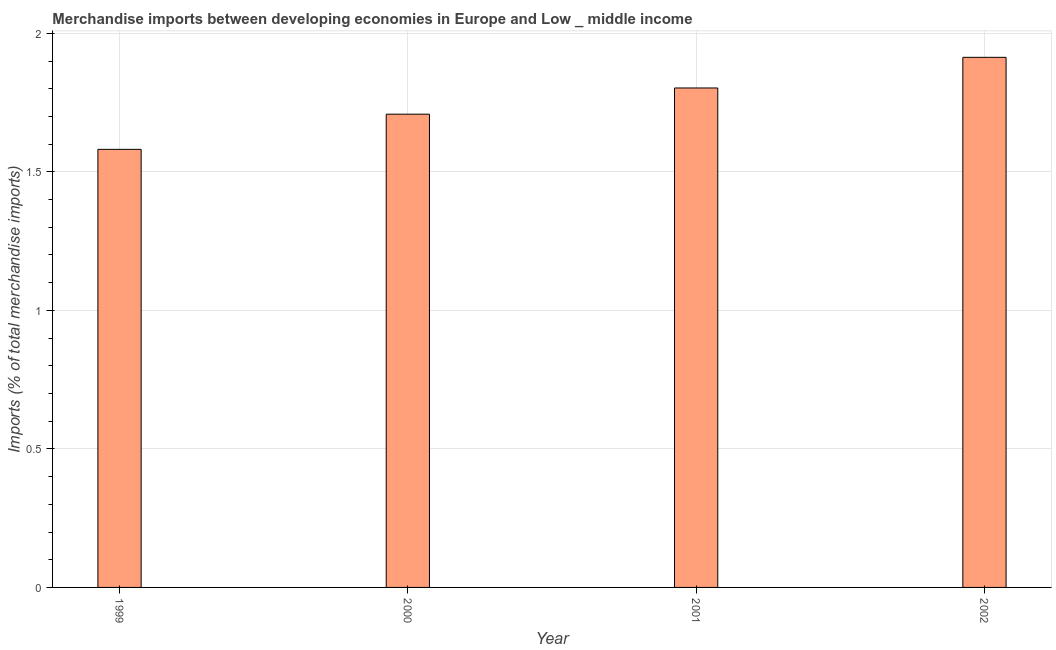What is the title of the graph?
Make the answer very short. Merchandise imports between developing economies in Europe and Low _ middle income. What is the label or title of the Y-axis?
Give a very brief answer. Imports (% of total merchandise imports). What is the merchandise imports in 2002?
Offer a very short reply. 1.91. Across all years, what is the maximum merchandise imports?
Provide a short and direct response. 1.91. Across all years, what is the minimum merchandise imports?
Your response must be concise. 1.58. In which year was the merchandise imports maximum?
Provide a succinct answer. 2002. In which year was the merchandise imports minimum?
Make the answer very short. 1999. What is the sum of the merchandise imports?
Give a very brief answer. 7.01. What is the difference between the merchandise imports in 2001 and 2002?
Offer a terse response. -0.11. What is the average merchandise imports per year?
Your answer should be very brief. 1.75. What is the median merchandise imports?
Provide a short and direct response. 1.76. What is the ratio of the merchandise imports in 1999 to that in 2000?
Give a very brief answer. 0.93. What is the difference between the highest and the second highest merchandise imports?
Your answer should be very brief. 0.11. What is the difference between the highest and the lowest merchandise imports?
Your answer should be compact. 0.33. In how many years, is the merchandise imports greater than the average merchandise imports taken over all years?
Give a very brief answer. 2. What is the difference between two consecutive major ticks on the Y-axis?
Provide a succinct answer. 0.5. What is the Imports (% of total merchandise imports) of 1999?
Ensure brevity in your answer.  1.58. What is the Imports (% of total merchandise imports) of 2000?
Your answer should be compact. 1.71. What is the Imports (% of total merchandise imports) of 2001?
Provide a short and direct response. 1.8. What is the Imports (% of total merchandise imports) of 2002?
Ensure brevity in your answer.  1.91. What is the difference between the Imports (% of total merchandise imports) in 1999 and 2000?
Keep it short and to the point. -0.13. What is the difference between the Imports (% of total merchandise imports) in 1999 and 2001?
Make the answer very short. -0.22. What is the difference between the Imports (% of total merchandise imports) in 1999 and 2002?
Make the answer very short. -0.33. What is the difference between the Imports (% of total merchandise imports) in 2000 and 2001?
Your answer should be very brief. -0.09. What is the difference between the Imports (% of total merchandise imports) in 2000 and 2002?
Provide a short and direct response. -0.21. What is the difference between the Imports (% of total merchandise imports) in 2001 and 2002?
Keep it short and to the point. -0.11. What is the ratio of the Imports (% of total merchandise imports) in 1999 to that in 2000?
Keep it short and to the point. 0.93. What is the ratio of the Imports (% of total merchandise imports) in 1999 to that in 2001?
Make the answer very short. 0.88. What is the ratio of the Imports (% of total merchandise imports) in 1999 to that in 2002?
Your answer should be compact. 0.83. What is the ratio of the Imports (% of total merchandise imports) in 2000 to that in 2001?
Your answer should be compact. 0.95. What is the ratio of the Imports (% of total merchandise imports) in 2000 to that in 2002?
Your answer should be very brief. 0.89. What is the ratio of the Imports (% of total merchandise imports) in 2001 to that in 2002?
Offer a very short reply. 0.94. 